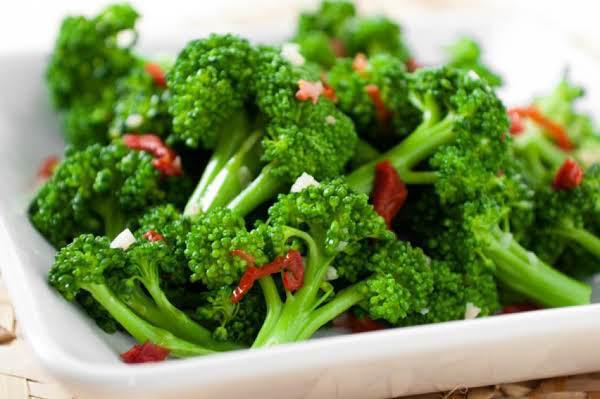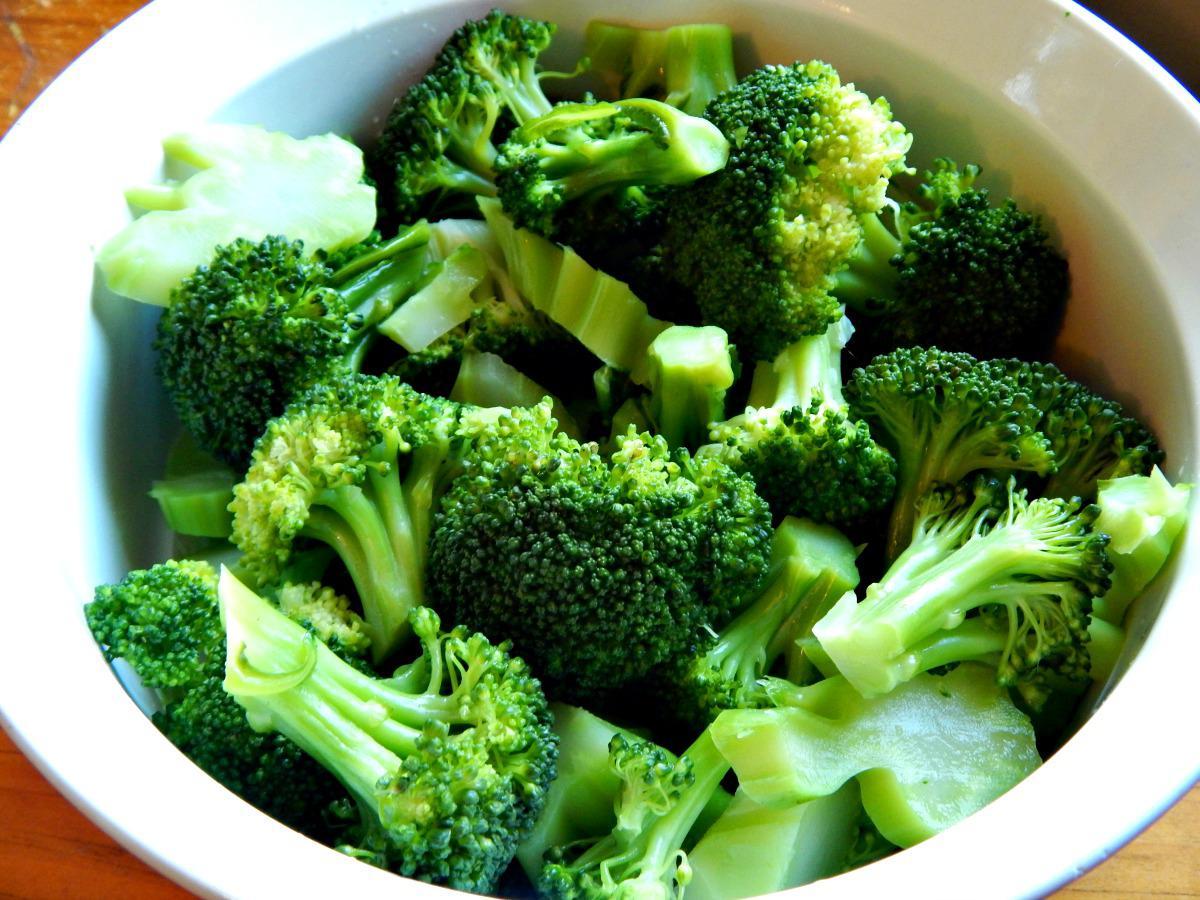The first image is the image on the left, the second image is the image on the right. Assess this claim about the two images: "The left and right image contains the same number of porcelain plates holding broccoli.". Correct or not? Answer yes or no. Yes. 